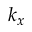<formula> <loc_0><loc_0><loc_500><loc_500>k _ { x }</formula> 